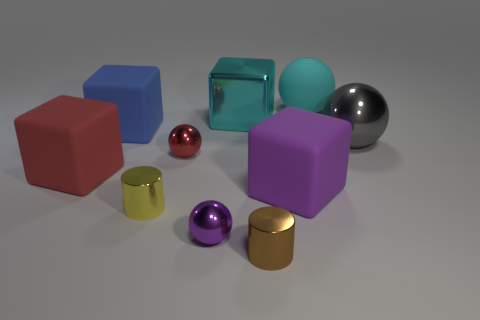Subtract all metal spheres. How many spheres are left? 1 Subtract all red spheres. How many spheres are left? 3 Subtract 3 spheres. How many spheres are left? 1 Subtract all big cyan matte cubes. Subtract all big shiny objects. How many objects are left? 8 Add 5 big cyan shiny blocks. How many big cyan shiny blocks are left? 6 Add 3 cyan matte things. How many cyan matte things exist? 4 Subtract 0 gray blocks. How many objects are left? 10 Subtract all cubes. How many objects are left? 6 Subtract all cyan cubes. Subtract all yellow cylinders. How many cubes are left? 3 